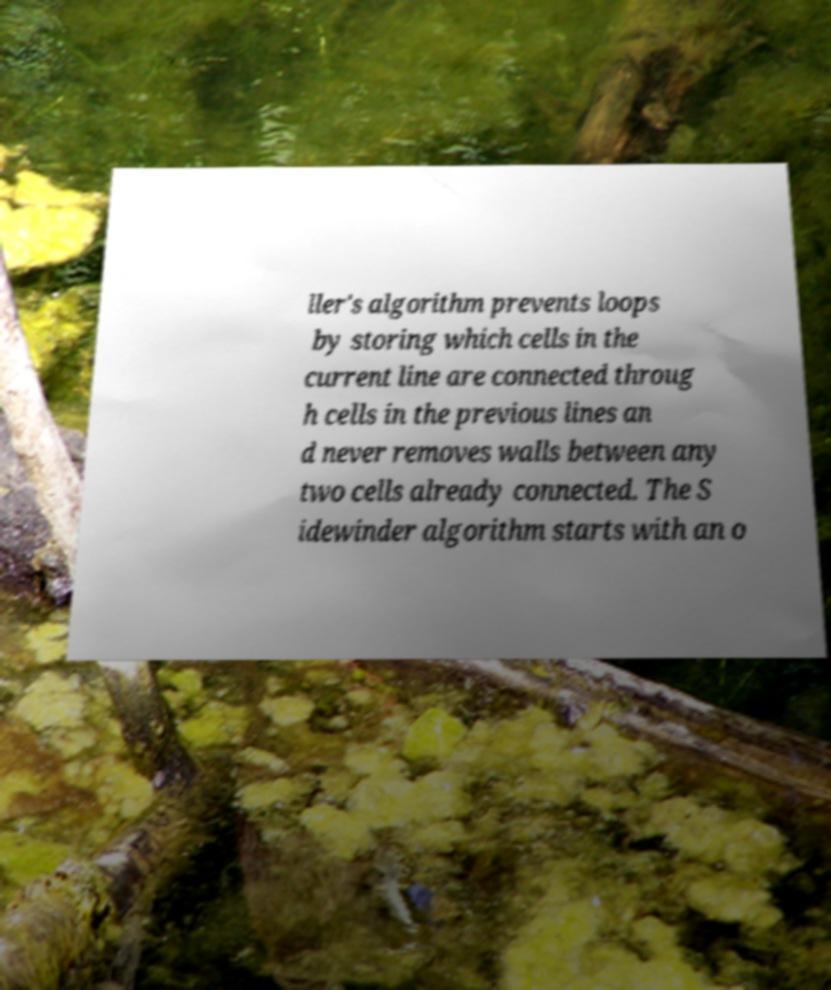There's text embedded in this image that I need extracted. Can you transcribe it verbatim? ller's algorithm prevents loops by storing which cells in the current line are connected throug h cells in the previous lines an d never removes walls between any two cells already connected. The S idewinder algorithm starts with an o 